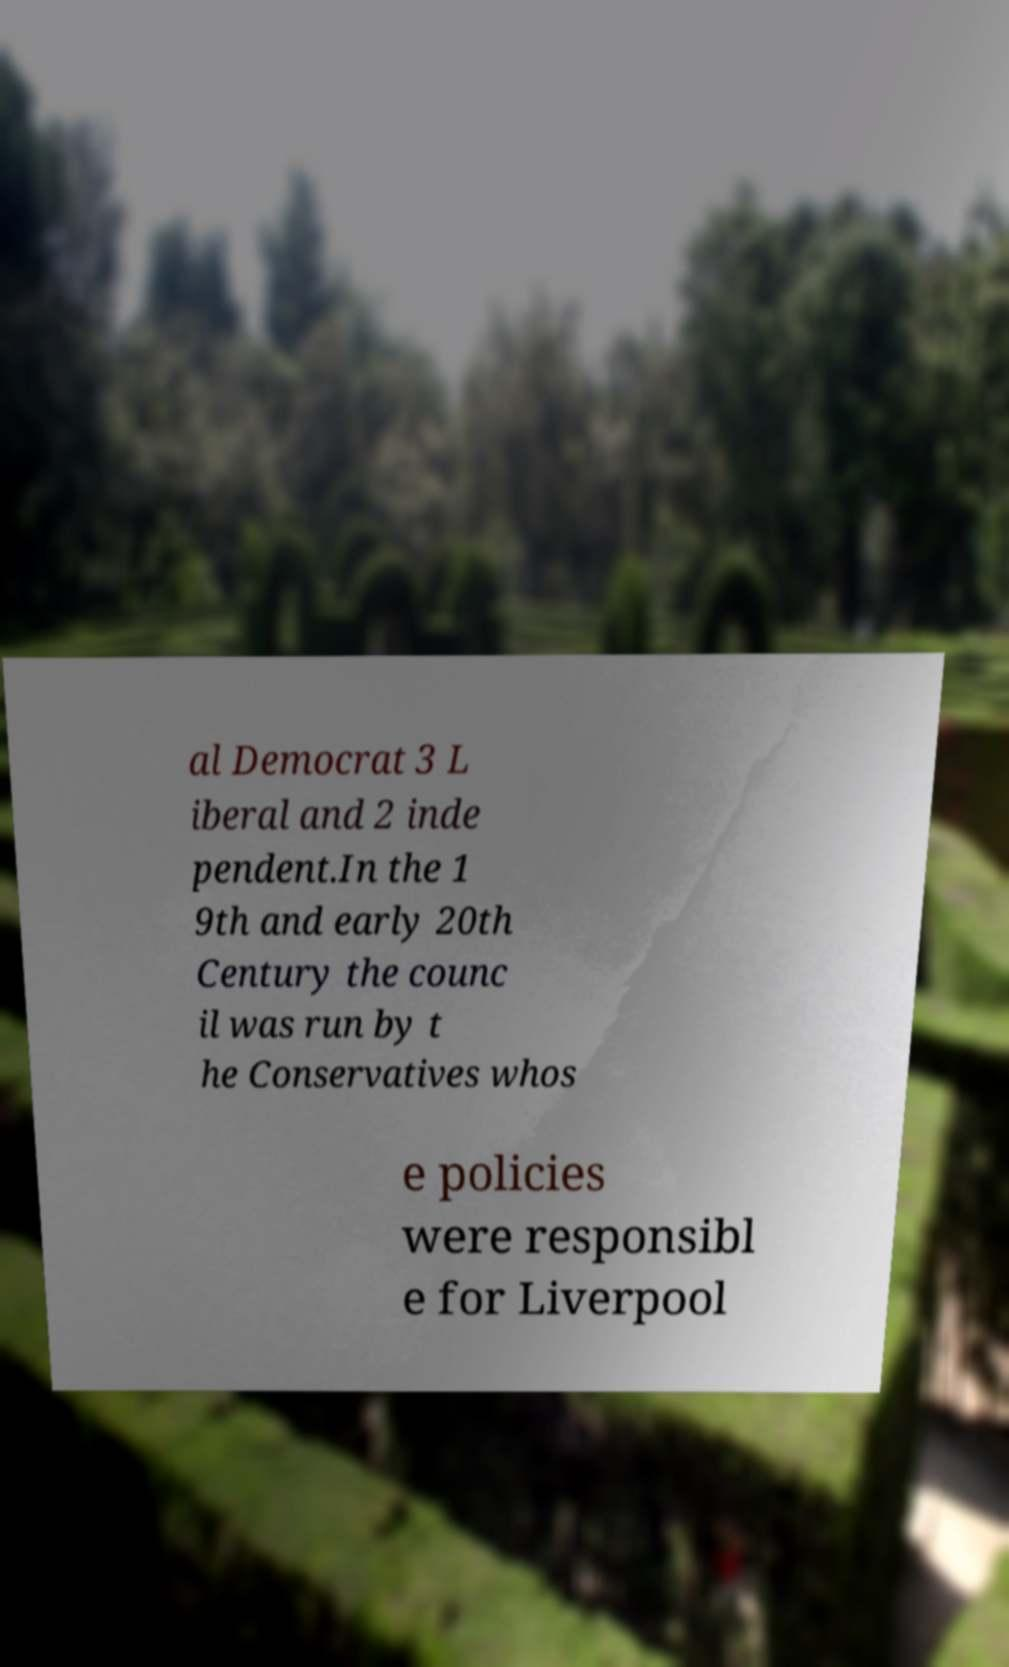Could you extract and type out the text from this image? al Democrat 3 L iberal and 2 inde pendent.In the 1 9th and early 20th Century the counc il was run by t he Conservatives whos e policies were responsibl e for Liverpool 